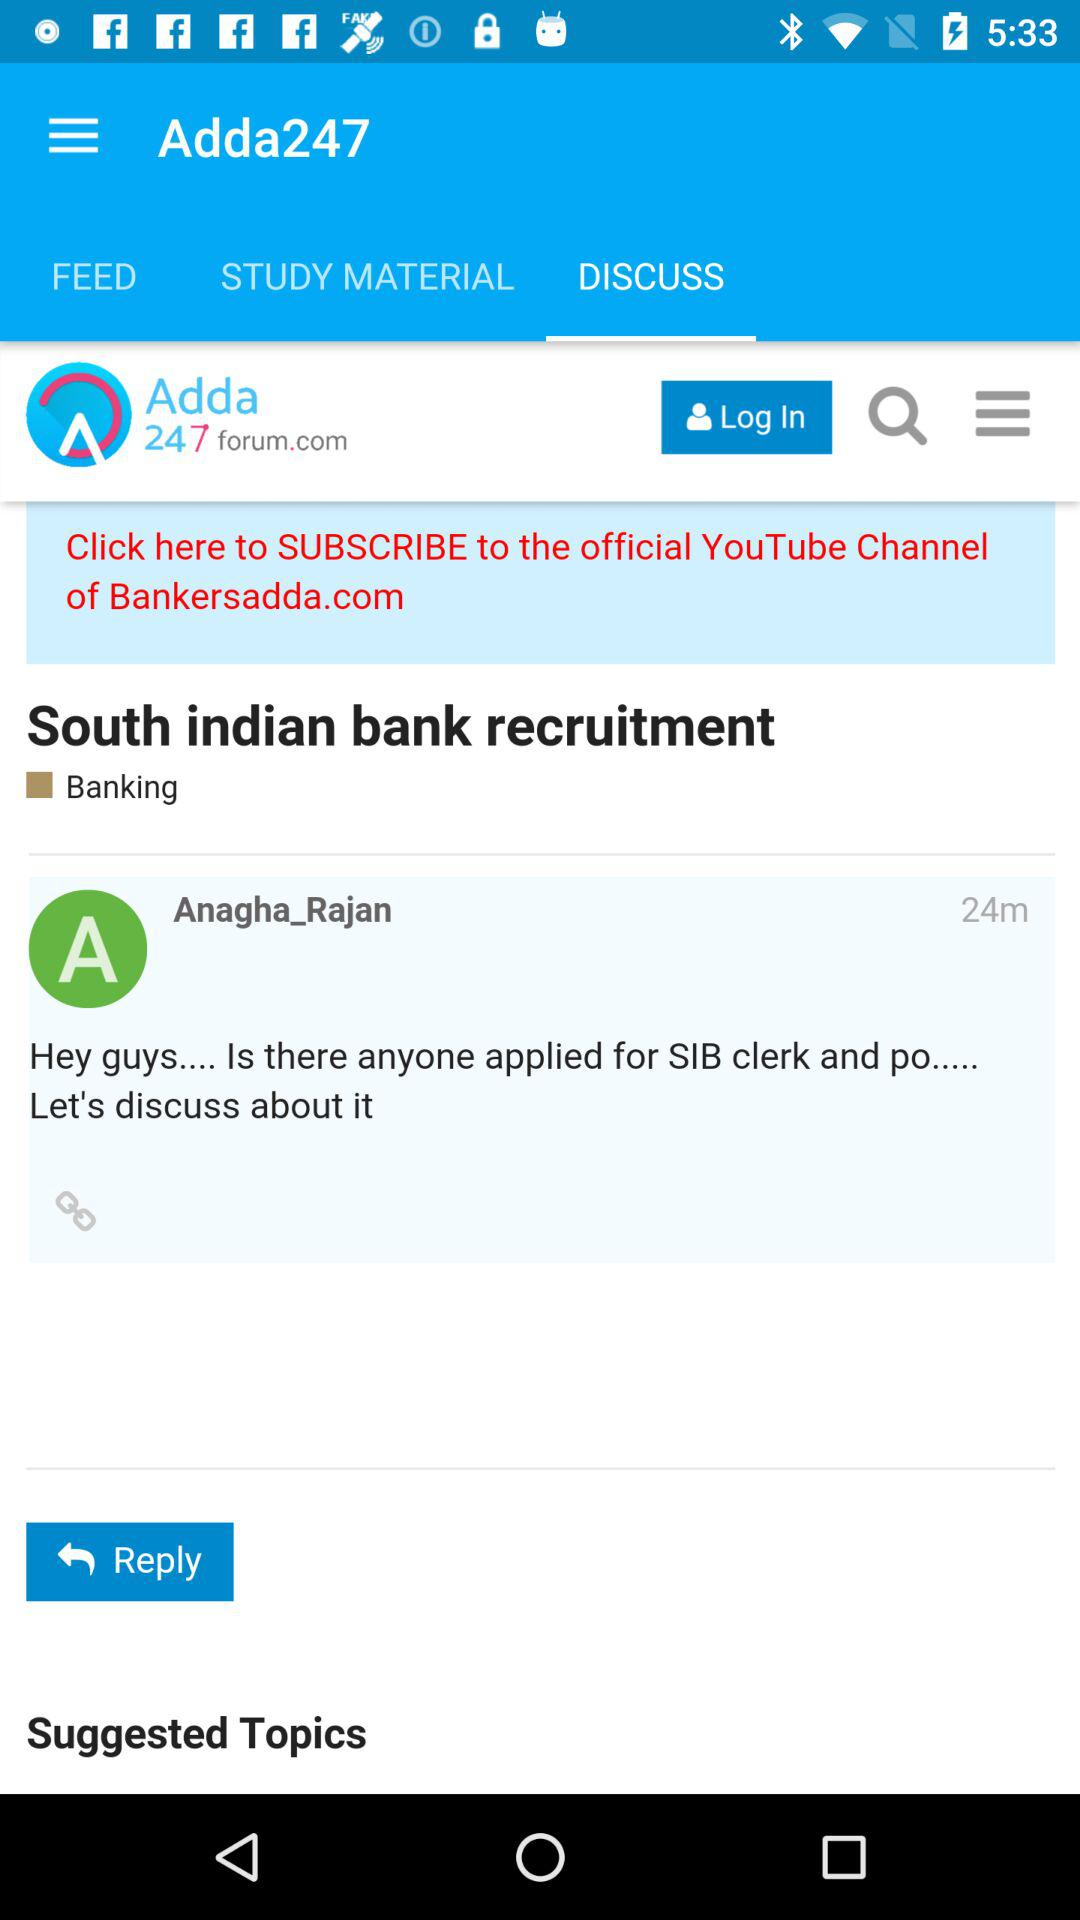What is the selected tab? The selected tab is "DISCUSS". 